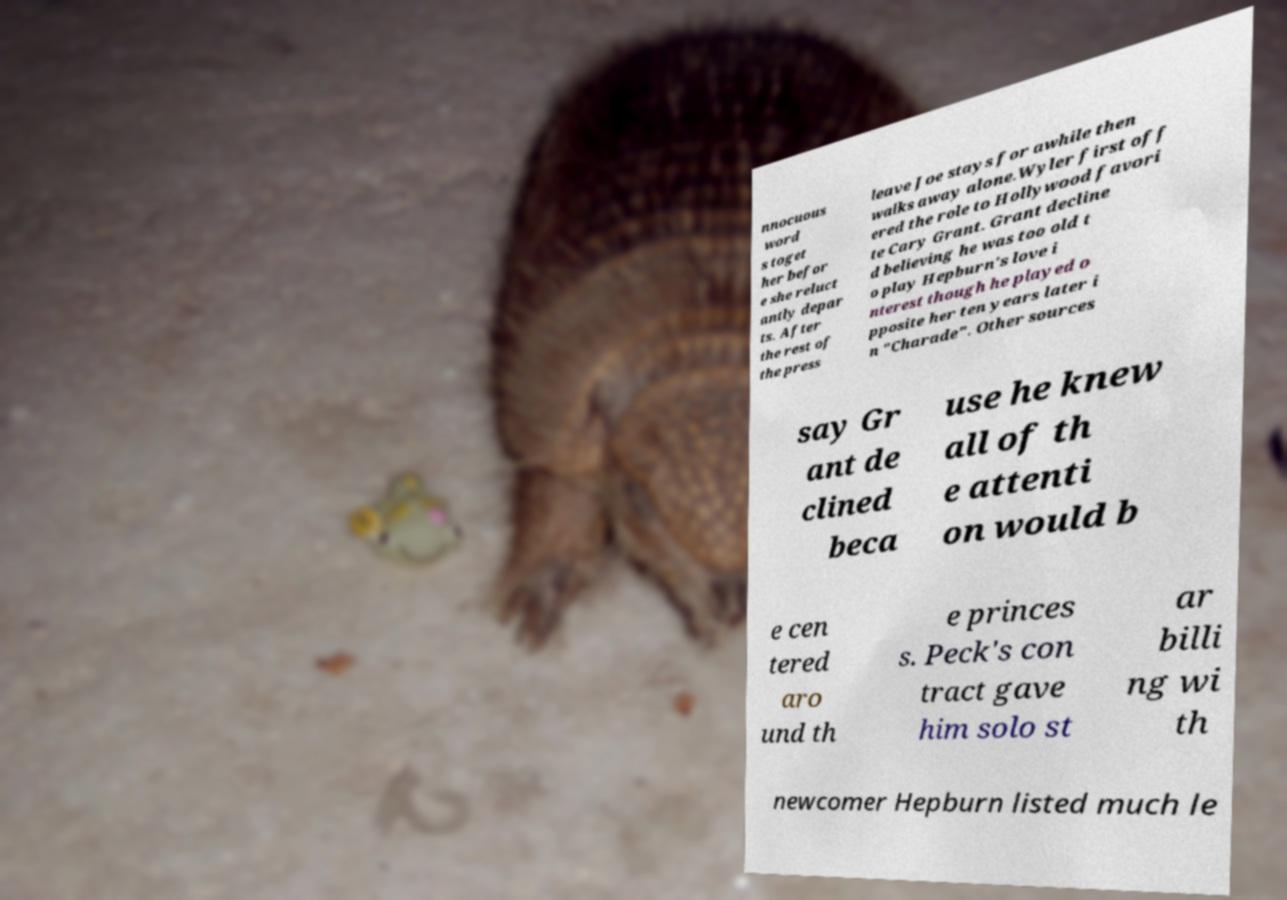Please read and relay the text visible in this image. What does it say? nnocuous word s toget her befor e she reluct antly depar ts. After the rest of the press leave Joe stays for awhile then walks away alone.Wyler first off ered the role to Hollywood favori te Cary Grant. Grant decline d believing he was too old t o play Hepburn's love i nterest though he played o pposite her ten years later i n "Charade". Other sources say Gr ant de clined beca use he knew all of th e attenti on would b e cen tered aro und th e princes s. Peck's con tract gave him solo st ar billi ng wi th newcomer Hepburn listed much le 